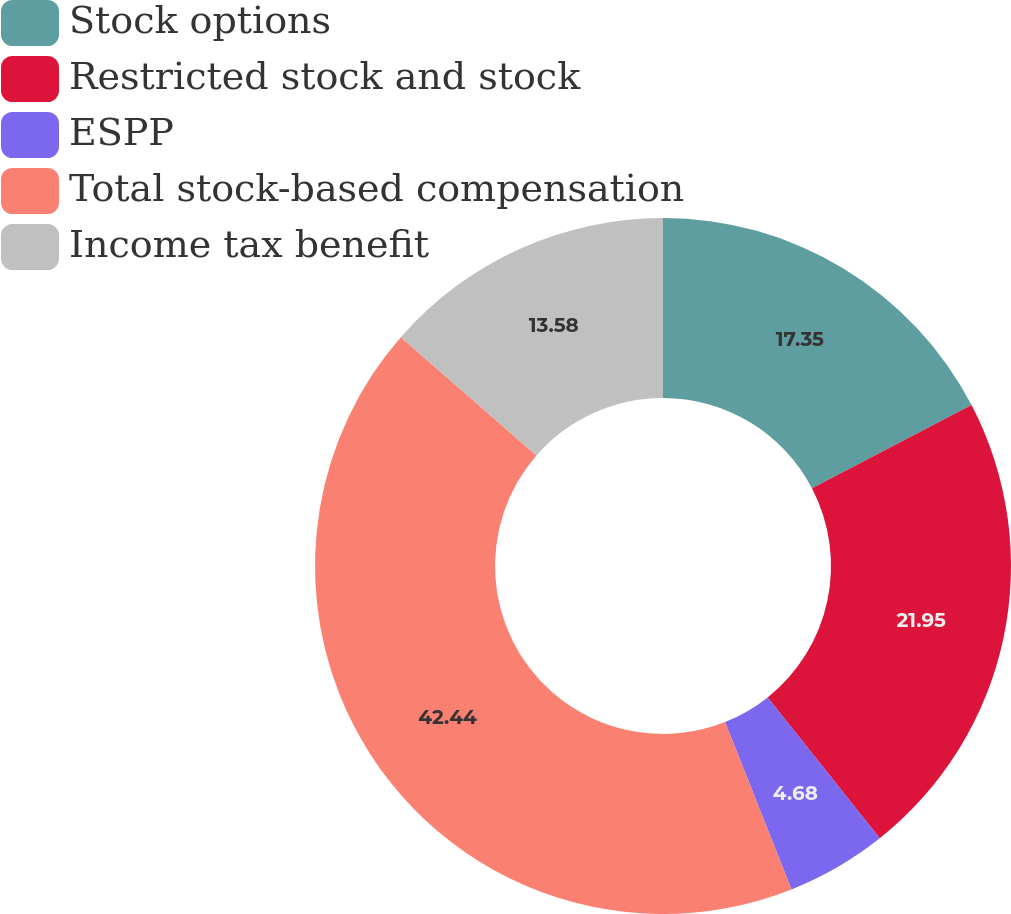Convert chart. <chart><loc_0><loc_0><loc_500><loc_500><pie_chart><fcel>Stock options<fcel>Restricted stock and stock<fcel>ESPP<fcel>Total stock-based compensation<fcel>Income tax benefit<nl><fcel>17.35%<fcel>21.95%<fcel>4.68%<fcel>42.44%<fcel>13.58%<nl></chart> 